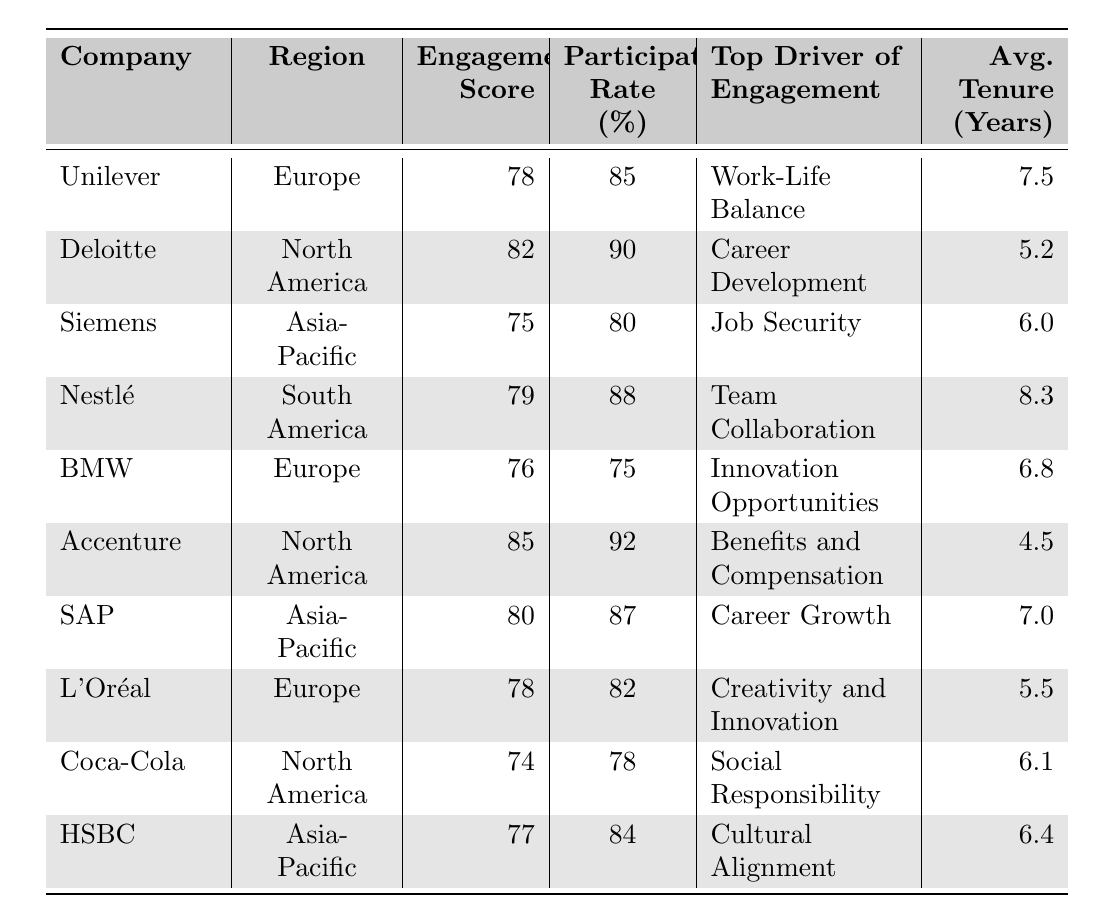What is the highest employee engagement score among the companies? The scores for each company are: Unilever 78, Deloitte 82, Siemens 75, Nestlé 79, BMW 76, Accenture 85, SAP 80, L'Oréal 78, Coca-Cola 74, and HSBC 77. The highest score is 85 from Accenture.
Answer: 85 Which company has the lowest participation rate? The participation rates are as follows: Unilever 85, Deloitte 90, Siemens 80, Nestlé 88, BMW 75, Accenture 92, SAP 87, L'Oréal 82, Coca-Cola 78, and HSBC 84. The lowest participation rate is 75 from BMW.
Answer: 75 Does Nestlé have a higher engagement score than Siemens? Nestlé has an engagement score of 79, while Siemens has a score of 75. Since 79 is greater than 75, the statement is true.
Answer: Yes What is the average tenure of employees in Accenture and Coca-Cola? Accenture has an average tenure of 4.5 years, and Coca-Cola has 6.1 years. Adding them together gives 4.5 + 6.1 = 10.6. To find the average, we divide by 2 (10.6 / 2 = 5.3).
Answer: 5.3 Which region has the highest average employee engagement score? The engagement scores by region are: Europe (78, 76, 78), North America (82, 85, 74), Asia-Pacific (75, 80, 77), and South America (79). First, we calculate the average for each region: Europe: (78 + 76 + 78) / 3 = 77.33; North America: (82 + 85 + 74) / 3 = 80.33; Asia-Pacific: (75 + 80 + 77) / 3 = 77.33; South America: 79. The highest average is 80.33 in North America.
Answer: North America True or False: L'Oréal's top driver of engagement is "Creativity and Innovation." The table explicitly states that L'Oréal's top driver of engagement is "Creativity and Innovation," confirming the statement is true.
Answer: True What is the difference in employee engagement scores between Accenture and Siemens? Accenture has a score of 85 and Siemens has a score of 75. The difference is 85 - 75 = 10.
Answer: 10 List the top driver of engagement for SAP. The table shows that SAP's top driver of engagement is "Career Growth."
Answer: Career Growth Calculate the median employee engagement score across all the companies. First, we list the engagement scores in ascending order: 74, 75, 76, 77, 78, 78, 79, 80, 82, 85. There are 10 scores (an even number), so the median is the average of the 5th and 6th scores: (78 + 78) / 2 = 78.
Answer: 78 Which company has the highest average tenure among the listed companies? The average tenures are: Unilever 7.5, Deloitte 5.2, Siemens 6.0, Nestlé 8.3, BMW 6.8, Accenture 4.5, SAP 7.0, L'Oréal 5.5, Coca-Cola 6.1, and HSBC 6.4. Nestlé, with 8.3 years, has the highest average tenure.
Answer: Nestlé 